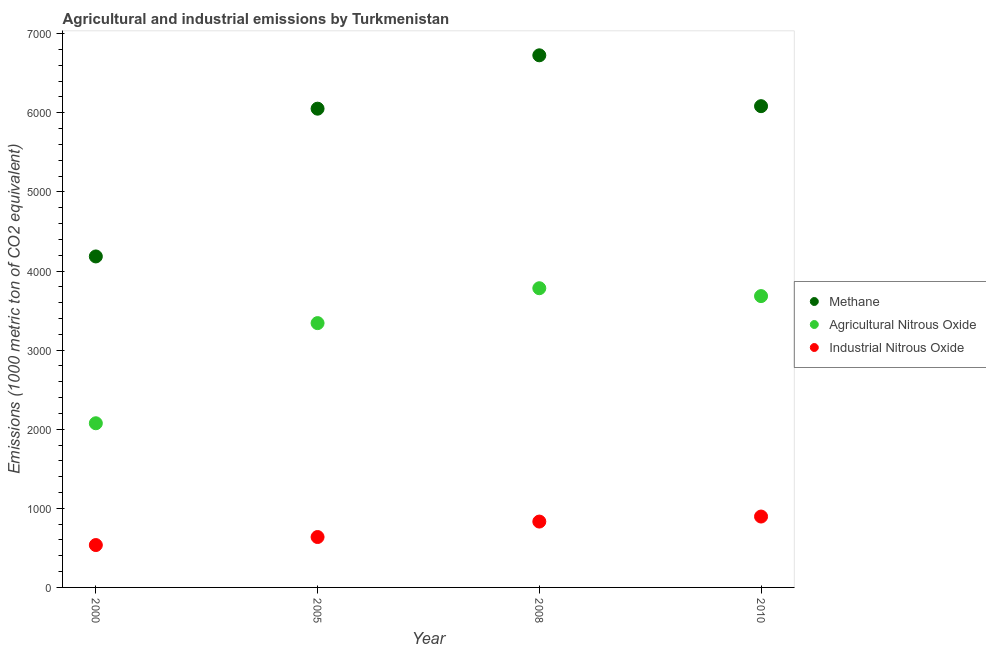Is the number of dotlines equal to the number of legend labels?
Give a very brief answer. Yes. What is the amount of industrial nitrous oxide emissions in 2008?
Offer a terse response. 832.5. Across all years, what is the maximum amount of methane emissions?
Ensure brevity in your answer.  6726.9. Across all years, what is the minimum amount of methane emissions?
Keep it short and to the point. 4184.3. What is the total amount of methane emissions in the graph?
Make the answer very short. 2.30e+04. What is the difference between the amount of methane emissions in 2005 and that in 2010?
Give a very brief answer. -31.7. What is the difference between the amount of agricultural nitrous oxide emissions in 2005 and the amount of industrial nitrous oxide emissions in 2008?
Offer a very short reply. 2508.8. What is the average amount of methane emissions per year?
Keep it short and to the point. 5761.88. In the year 2000, what is the difference between the amount of methane emissions and amount of agricultural nitrous oxide emissions?
Your answer should be very brief. 2109. In how many years, is the amount of industrial nitrous oxide emissions greater than 5400 metric ton?
Make the answer very short. 0. What is the ratio of the amount of industrial nitrous oxide emissions in 2005 to that in 2008?
Offer a terse response. 0.77. Is the amount of agricultural nitrous oxide emissions in 2000 less than that in 2008?
Provide a succinct answer. Yes. Is the difference between the amount of methane emissions in 2005 and 2008 greater than the difference between the amount of industrial nitrous oxide emissions in 2005 and 2008?
Your answer should be compact. No. What is the difference between the highest and the second highest amount of industrial nitrous oxide emissions?
Provide a short and direct response. 63.6. What is the difference between the highest and the lowest amount of agricultural nitrous oxide emissions?
Provide a short and direct response. 1707.1. In how many years, is the amount of industrial nitrous oxide emissions greater than the average amount of industrial nitrous oxide emissions taken over all years?
Your answer should be compact. 2. Is it the case that in every year, the sum of the amount of methane emissions and amount of agricultural nitrous oxide emissions is greater than the amount of industrial nitrous oxide emissions?
Make the answer very short. Yes. Is the amount of methane emissions strictly greater than the amount of agricultural nitrous oxide emissions over the years?
Provide a succinct answer. Yes. Is the amount of methane emissions strictly less than the amount of agricultural nitrous oxide emissions over the years?
Provide a succinct answer. No. Are the values on the major ticks of Y-axis written in scientific E-notation?
Your answer should be very brief. No. Does the graph contain any zero values?
Your answer should be very brief. No. Does the graph contain grids?
Offer a very short reply. No. Where does the legend appear in the graph?
Provide a short and direct response. Center right. How many legend labels are there?
Offer a terse response. 3. How are the legend labels stacked?
Provide a short and direct response. Vertical. What is the title of the graph?
Ensure brevity in your answer.  Agricultural and industrial emissions by Turkmenistan. Does "Taxes on goods and services" appear as one of the legend labels in the graph?
Offer a terse response. No. What is the label or title of the X-axis?
Ensure brevity in your answer.  Year. What is the label or title of the Y-axis?
Your answer should be very brief. Emissions (1000 metric ton of CO2 equivalent). What is the Emissions (1000 metric ton of CO2 equivalent) in Methane in 2000?
Ensure brevity in your answer.  4184.3. What is the Emissions (1000 metric ton of CO2 equivalent) of Agricultural Nitrous Oxide in 2000?
Provide a succinct answer. 2075.3. What is the Emissions (1000 metric ton of CO2 equivalent) in Industrial Nitrous Oxide in 2000?
Keep it short and to the point. 535.7. What is the Emissions (1000 metric ton of CO2 equivalent) of Methane in 2005?
Make the answer very short. 6052.3. What is the Emissions (1000 metric ton of CO2 equivalent) in Agricultural Nitrous Oxide in 2005?
Provide a short and direct response. 3341.3. What is the Emissions (1000 metric ton of CO2 equivalent) in Industrial Nitrous Oxide in 2005?
Provide a succinct answer. 637.2. What is the Emissions (1000 metric ton of CO2 equivalent) of Methane in 2008?
Keep it short and to the point. 6726.9. What is the Emissions (1000 metric ton of CO2 equivalent) of Agricultural Nitrous Oxide in 2008?
Your answer should be very brief. 3782.4. What is the Emissions (1000 metric ton of CO2 equivalent) in Industrial Nitrous Oxide in 2008?
Your answer should be compact. 832.5. What is the Emissions (1000 metric ton of CO2 equivalent) in Methane in 2010?
Your response must be concise. 6084. What is the Emissions (1000 metric ton of CO2 equivalent) of Agricultural Nitrous Oxide in 2010?
Provide a short and direct response. 3682.9. What is the Emissions (1000 metric ton of CO2 equivalent) in Industrial Nitrous Oxide in 2010?
Provide a succinct answer. 896.1. Across all years, what is the maximum Emissions (1000 metric ton of CO2 equivalent) of Methane?
Make the answer very short. 6726.9. Across all years, what is the maximum Emissions (1000 metric ton of CO2 equivalent) of Agricultural Nitrous Oxide?
Make the answer very short. 3782.4. Across all years, what is the maximum Emissions (1000 metric ton of CO2 equivalent) of Industrial Nitrous Oxide?
Make the answer very short. 896.1. Across all years, what is the minimum Emissions (1000 metric ton of CO2 equivalent) of Methane?
Your answer should be compact. 4184.3. Across all years, what is the minimum Emissions (1000 metric ton of CO2 equivalent) in Agricultural Nitrous Oxide?
Give a very brief answer. 2075.3. Across all years, what is the minimum Emissions (1000 metric ton of CO2 equivalent) in Industrial Nitrous Oxide?
Your response must be concise. 535.7. What is the total Emissions (1000 metric ton of CO2 equivalent) in Methane in the graph?
Your answer should be very brief. 2.30e+04. What is the total Emissions (1000 metric ton of CO2 equivalent) in Agricultural Nitrous Oxide in the graph?
Offer a very short reply. 1.29e+04. What is the total Emissions (1000 metric ton of CO2 equivalent) of Industrial Nitrous Oxide in the graph?
Offer a terse response. 2901.5. What is the difference between the Emissions (1000 metric ton of CO2 equivalent) in Methane in 2000 and that in 2005?
Your answer should be compact. -1868. What is the difference between the Emissions (1000 metric ton of CO2 equivalent) in Agricultural Nitrous Oxide in 2000 and that in 2005?
Provide a succinct answer. -1266. What is the difference between the Emissions (1000 metric ton of CO2 equivalent) in Industrial Nitrous Oxide in 2000 and that in 2005?
Offer a very short reply. -101.5. What is the difference between the Emissions (1000 metric ton of CO2 equivalent) of Methane in 2000 and that in 2008?
Your answer should be compact. -2542.6. What is the difference between the Emissions (1000 metric ton of CO2 equivalent) in Agricultural Nitrous Oxide in 2000 and that in 2008?
Make the answer very short. -1707.1. What is the difference between the Emissions (1000 metric ton of CO2 equivalent) in Industrial Nitrous Oxide in 2000 and that in 2008?
Offer a very short reply. -296.8. What is the difference between the Emissions (1000 metric ton of CO2 equivalent) in Methane in 2000 and that in 2010?
Offer a very short reply. -1899.7. What is the difference between the Emissions (1000 metric ton of CO2 equivalent) of Agricultural Nitrous Oxide in 2000 and that in 2010?
Ensure brevity in your answer.  -1607.6. What is the difference between the Emissions (1000 metric ton of CO2 equivalent) of Industrial Nitrous Oxide in 2000 and that in 2010?
Your answer should be compact. -360.4. What is the difference between the Emissions (1000 metric ton of CO2 equivalent) in Methane in 2005 and that in 2008?
Keep it short and to the point. -674.6. What is the difference between the Emissions (1000 metric ton of CO2 equivalent) in Agricultural Nitrous Oxide in 2005 and that in 2008?
Provide a succinct answer. -441.1. What is the difference between the Emissions (1000 metric ton of CO2 equivalent) in Industrial Nitrous Oxide in 2005 and that in 2008?
Make the answer very short. -195.3. What is the difference between the Emissions (1000 metric ton of CO2 equivalent) in Methane in 2005 and that in 2010?
Offer a very short reply. -31.7. What is the difference between the Emissions (1000 metric ton of CO2 equivalent) in Agricultural Nitrous Oxide in 2005 and that in 2010?
Provide a succinct answer. -341.6. What is the difference between the Emissions (1000 metric ton of CO2 equivalent) in Industrial Nitrous Oxide in 2005 and that in 2010?
Offer a very short reply. -258.9. What is the difference between the Emissions (1000 metric ton of CO2 equivalent) in Methane in 2008 and that in 2010?
Give a very brief answer. 642.9. What is the difference between the Emissions (1000 metric ton of CO2 equivalent) of Agricultural Nitrous Oxide in 2008 and that in 2010?
Provide a succinct answer. 99.5. What is the difference between the Emissions (1000 metric ton of CO2 equivalent) in Industrial Nitrous Oxide in 2008 and that in 2010?
Keep it short and to the point. -63.6. What is the difference between the Emissions (1000 metric ton of CO2 equivalent) of Methane in 2000 and the Emissions (1000 metric ton of CO2 equivalent) of Agricultural Nitrous Oxide in 2005?
Provide a short and direct response. 843. What is the difference between the Emissions (1000 metric ton of CO2 equivalent) in Methane in 2000 and the Emissions (1000 metric ton of CO2 equivalent) in Industrial Nitrous Oxide in 2005?
Ensure brevity in your answer.  3547.1. What is the difference between the Emissions (1000 metric ton of CO2 equivalent) in Agricultural Nitrous Oxide in 2000 and the Emissions (1000 metric ton of CO2 equivalent) in Industrial Nitrous Oxide in 2005?
Provide a succinct answer. 1438.1. What is the difference between the Emissions (1000 metric ton of CO2 equivalent) in Methane in 2000 and the Emissions (1000 metric ton of CO2 equivalent) in Agricultural Nitrous Oxide in 2008?
Make the answer very short. 401.9. What is the difference between the Emissions (1000 metric ton of CO2 equivalent) in Methane in 2000 and the Emissions (1000 metric ton of CO2 equivalent) in Industrial Nitrous Oxide in 2008?
Make the answer very short. 3351.8. What is the difference between the Emissions (1000 metric ton of CO2 equivalent) in Agricultural Nitrous Oxide in 2000 and the Emissions (1000 metric ton of CO2 equivalent) in Industrial Nitrous Oxide in 2008?
Keep it short and to the point. 1242.8. What is the difference between the Emissions (1000 metric ton of CO2 equivalent) in Methane in 2000 and the Emissions (1000 metric ton of CO2 equivalent) in Agricultural Nitrous Oxide in 2010?
Keep it short and to the point. 501.4. What is the difference between the Emissions (1000 metric ton of CO2 equivalent) of Methane in 2000 and the Emissions (1000 metric ton of CO2 equivalent) of Industrial Nitrous Oxide in 2010?
Keep it short and to the point. 3288.2. What is the difference between the Emissions (1000 metric ton of CO2 equivalent) in Agricultural Nitrous Oxide in 2000 and the Emissions (1000 metric ton of CO2 equivalent) in Industrial Nitrous Oxide in 2010?
Offer a very short reply. 1179.2. What is the difference between the Emissions (1000 metric ton of CO2 equivalent) of Methane in 2005 and the Emissions (1000 metric ton of CO2 equivalent) of Agricultural Nitrous Oxide in 2008?
Provide a short and direct response. 2269.9. What is the difference between the Emissions (1000 metric ton of CO2 equivalent) in Methane in 2005 and the Emissions (1000 metric ton of CO2 equivalent) in Industrial Nitrous Oxide in 2008?
Provide a short and direct response. 5219.8. What is the difference between the Emissions (1000 metric ton of CO2 equivalent) in Agricultural Nitrous Oxide in 2005 and the Emissions (1000 metric ton of CO2 equivalent) in Industrial Nitrous Oxide in 2008?
Provide a short and direct response. 2508.8. What is the difference between the Emissions (1000 metric ton of CO2 equivalent) in Methane in 2005 and the Emissions (1000 metric ton of CO2 equivalent) in Agricultural Nitrous Oxide in 2010?
Your response must be concise. 2369.4. What is the difference between the Emissions (1000 metric ton of CO2 equivalent) of Methane in 2005 and the Emissions (1000 metric ton of CO2 equivalent) of Industrial Nitrous Oxide in 2010?
Provide a short and direct response. 5156.2. What is the difference between the Emissions (1000 metric ton of CO2 equivalent) of Agricultural Nitrous Oxide in 2005 and the Emissions (1000 metric ton of CO2 equivalent) of Industrial Nitrous Oxide in 2010?
Provide a short and direct response. 2445.2. What is the difference between the Emissions (1000 metric ton of CO2 equivalent) of Methane in 2008 and the Emissions (1000 metric ton of CO2 equivalent) of Agricultural Nitrous Oxide in 2010?
Ensure brevity in your answer.  3044. What is the difference between the Emissions (1000 metric ton of CO2 equivalent) of Methane in 2008 and the Emissions (1000 metric ton of CO2 equivalent) of Industrial Nitrous Oxide in 2010?
Your response must be concise. 5830.8. What is the difference between the Emissions (1000 metric ton of CO2 equivalent) in Agricultural Nitrous Oxide in 2008 and the Emissions (1000 metric ton of CO2 equivalent) in Industrial Nitrous Oxide in 2010?
Your answer should be very brief. 2886.3. What is the average Emissions (1000 metric ton of CO2 equivalent) of Methane per year?
Your response must be concise. 5761.88. What is the average Emissions (1000 metric ton of CO2 equivalent) of Agricultural Nitrous Oxide per year?
Ensure brevity in your answer.  3220.47. What is the average Emissions (1000 metric ton of CO2 equivalent) of Industrial Nitrous Oxide per year?
Provide a succinct answer. 725.38. In the year 2000, what is the difference between the Emissions (1000 metric ton of CO2 equivalent) in Methane and Emissions (1000 metric ton of CO2 equivalent) in Agricultural Nitrous Oxide?
Your response must be concise. 2109. In the year 2000, what is the difference between the Emissions (1000 metric ton of CO2 equivalent) of Methane and Emissions (1000 metric ton of CO2 equivalent) of Industrial Nitrous Oxide?
Offer a very short reply. 3648.6. In the year 2000, what is the difference between the Emissions (1000 metric ton of CO2 equivalent) in Agricultural Nitrous Oxide and Emissions (1000 metric ton of CO2 equivalent) in Industrial Nitrous Oxide?
Offer a terse response. 1539.6. In the year 2005, what is the difference between the Emissions (1000 metric ton of CO2 equivalent) of Methane and Emissions (1000 metric ton of CO2 equivalent) of Agricultural Nitrous Oxide?
Provide a short and direct response. 2711. In the year 2005, what is the difference between the Emissions (1000 metric ton of CO2 equivalent) in Methane and Emissions (1000 metric ton of CO2 equivalent) in Industrial Nitrous Oxide?
Offer a very short reply. 5415.1. In the year 2005, what is the difference between the Emissions (1000 metric ton of CO2 equivalent) of Agricultural Nitrous Oxide and Emissions (1000 metric ton of CO2 equivalent) of Industrial Nitrous Oxide?
Your answer should be compact. 2704.1. In the year 2008, what is the difference between the Emissions (1000 metric ton of CO2 equivalent) in Methane and Emissions (1000 metric ton of CO2 equivalent) in Agricultural Nitrous Oxide?
Ensure brevity in your answer.  2944.5. In the year 2008, what is the difference between the Emissions (1000 metric ton of CO2 equivalent) of Methane and Emissions (1000 metric ton of CO2 equivalent) of Industrial Nitrous Oxide?
Your response must be concise. 5894.4. In the year 2008, what is the difference between the Emissions (1000 metric ton of CO2 equivalent) of Agricultural Nitrous Oxide and Emissions (1000 metric ton of CO2 equivalent) of Industrial Nitrous Oxide?
Your response must be concise. 2949.9. In the year 2010, what is the difference between the Emissions (1000 metric ton of CO2 equivalent) of Methane and Emissions (1000 metric ton of CO2 equivalent) of Agricultural Nitrous Oxide?
Provide a short and direct response. 2401.1. In the year 2010, what is the difference between the Emissions (1000 metric ton of CO2 equivalent) of Methane and Emissions (1000 metric ton of CO2 equivalent) of Industrial Nitrous Oxide?
Give a very brief answer. 5187.9. In the year 2010, what is the difference between the Emissions (1000 metric ton of CO2 equivalent) in Agricultural Nitrous Oxide and Emissions (1000 metric ton of CO2 equivalent) in Industrial Nitrous Oxide?
Keep it short and to the point. 2786.8. What is the ratio of the Emissions (1000 metric ton of CO2 equivalent) in Methane in 2000 to that in 2005?
Keep it short and to the point. 0.69. What is the ratio of the Emissions (1000 metric ton of CO2 equivalent) of Agricultural Nitrous Oxide in 2000 to that in 2005?
Make the answer very short. 0.62. What is the ratio of the Emissions (1000 metric ton of CO2 equivalent) of Industrial Nitrous Oxide in 2000 to that in 2005?
Offer a very short reply. 0.84. What is the ratio of the Emissions (1000 metric ton of CO2 equivalent) in Methane in 2000 to that in 2008?
Offer a terse response. 0.62. What is the ratio of the Emissions (1000 metric ton of CO2 equivalent) of Agricultural Nitrous Oxide in 2000 to that in 2008?
Offer a terse response. 0.55. What is the ratio of the Emissions (1000 metric ton of CO2 equivalent) in Industrial Nitrous Oxide in 2000 to that in 2008?
Offer a very short reply. 0.64. What is the ratio of the Emissions (1000 metric ton of CO2 equivalent) of Methane in 2000 to that in 2010?
Keep it short and to the point. 0.69. What is the ratio of the Emissions (1000 metric ton of CO2 equivalent) in Agricultural Nitrous Oxide in 2000 to that in 2010?
Make the answer very short. 0.56. What is the ratio of the Emissions (1000 metric ton of CO2 equivalent) of Industrial Nitrous Oxide in 2000 to that in 2010?
Provide a short and direct response. 0.6. What is the ratio of the Emissions (1000 metric ton of CO2 equivalent) in Methane in 2005 to that in 2008?
Provide a succinct answer. 0.9. What is the ratio of the Emissions (1000 metric ton of CO2 equivalent) in Agricultural Nitrous Oxide in 2005 to that in 2008?
Your response must be concise. 0.88. What is the ratio of the Emissions (1000 metric ton of CO2 equivalent) of Industrial Nitrous Oxide in 2005 to that in 2008?
Offer a very short reply. 0.77. What is the ratio of the Emissions (1000 metric ton of CO2 equivalent) of Agricultural Nitrous Oxide in 2005 to that in 2010?
Provide a short and direct response. 0.91. What is the ratio of the Emissions (1000 metric ton of CO2 equivalent) in Industrial Nitrous Oxide in 2005 to that in 2010?
Offer a terse response. 0.71. What is the ratio of the Emissions (1000 metric ton of CO2 equivalent) of Methane in 2008 to that in 2010?
Give a very brief answer. 1.11. What is the ratio of the Emissions (1000 metric ton of CO2 equivalent) of Industrial Nitrous Oxide in 2008 to that in 2010?
Keep it short and to the point. 0.93. What is the difference between the highest and the second highest Emissions (1000 metric ton of CO2 equivalent) in Methane?
Give a very brief answer. 642.9. What is the difference between the highest and the second highest Emissions (1000 metric ton of CO2 equivalent) in Agricultural Nitrous Oxide?
Ensure brevity in your answer.  99.5. What is the difference between the highest and the second highest Emissions (1000 metric ton of CO2 equivalent) in Industrial Nitrous Oxide?
Keep it short and to the point. 63.6. What is the difference between the highest and the lowest Emissions (1000 metric ton of CO2 equivalent) of Methane?
Provide a succinct answer. 2542.6. What is the difference between the highest and the lowest Emissions (1000 metric ton of CO2 equivalent) of Agricultural Nitrous Oxide?
Your answer should be compact. 1707.1. What is the difference between the highest and the lowest Emissions (1000 metric ton of CO2 equivalent) of Industrial Nitrous Oxide?
Offer a terse response. 360.4. 